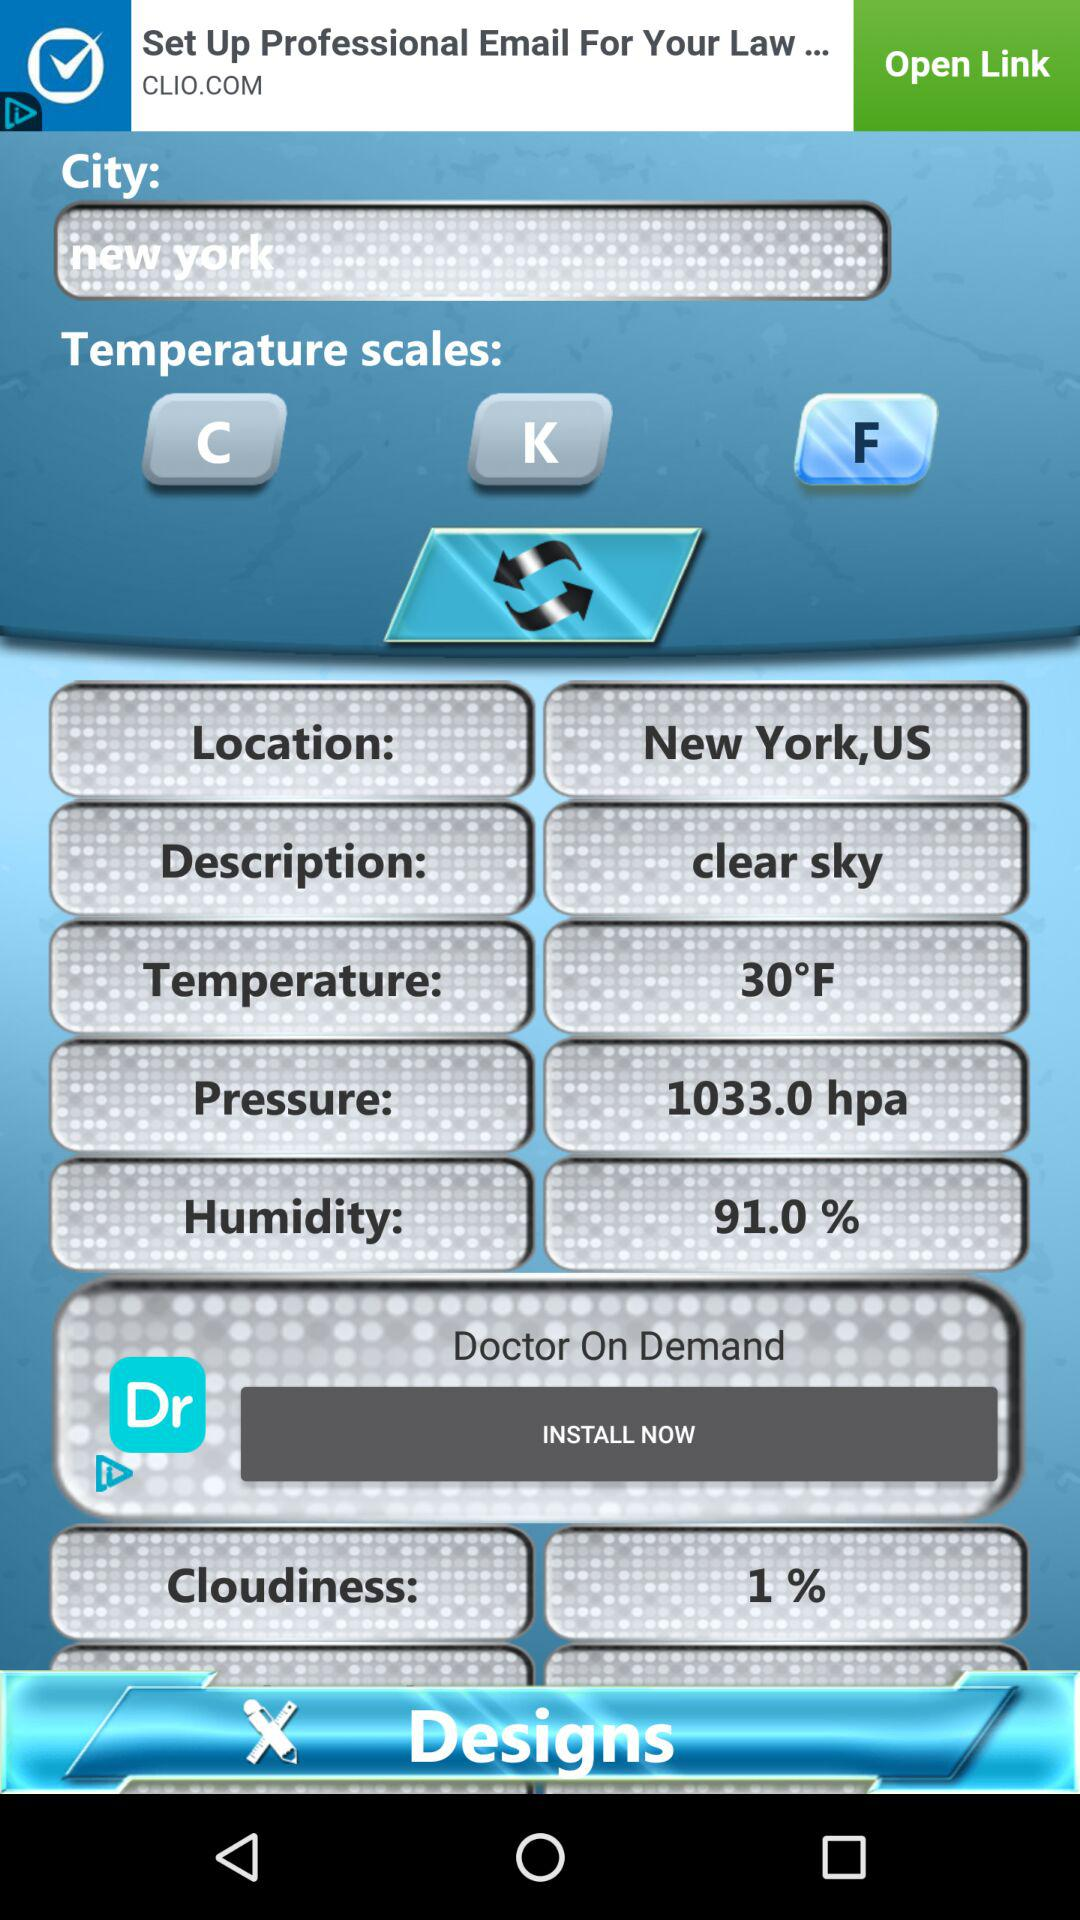What is the pressure measured in New York? The measured pressure is 1033.0 hPa. 